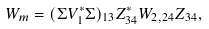Convert formula to latex. <formula><loc_0><loc_0><loc_500><loc_500>W _ { m } = ( \Sigma V _ { 1 } ^ { * } \Sigma ) _ { 1 3 } Z ^ { * } _ { 3 4 } W _ { 2 , 2 4 } Z _ { 3 4 } ,</formula> 